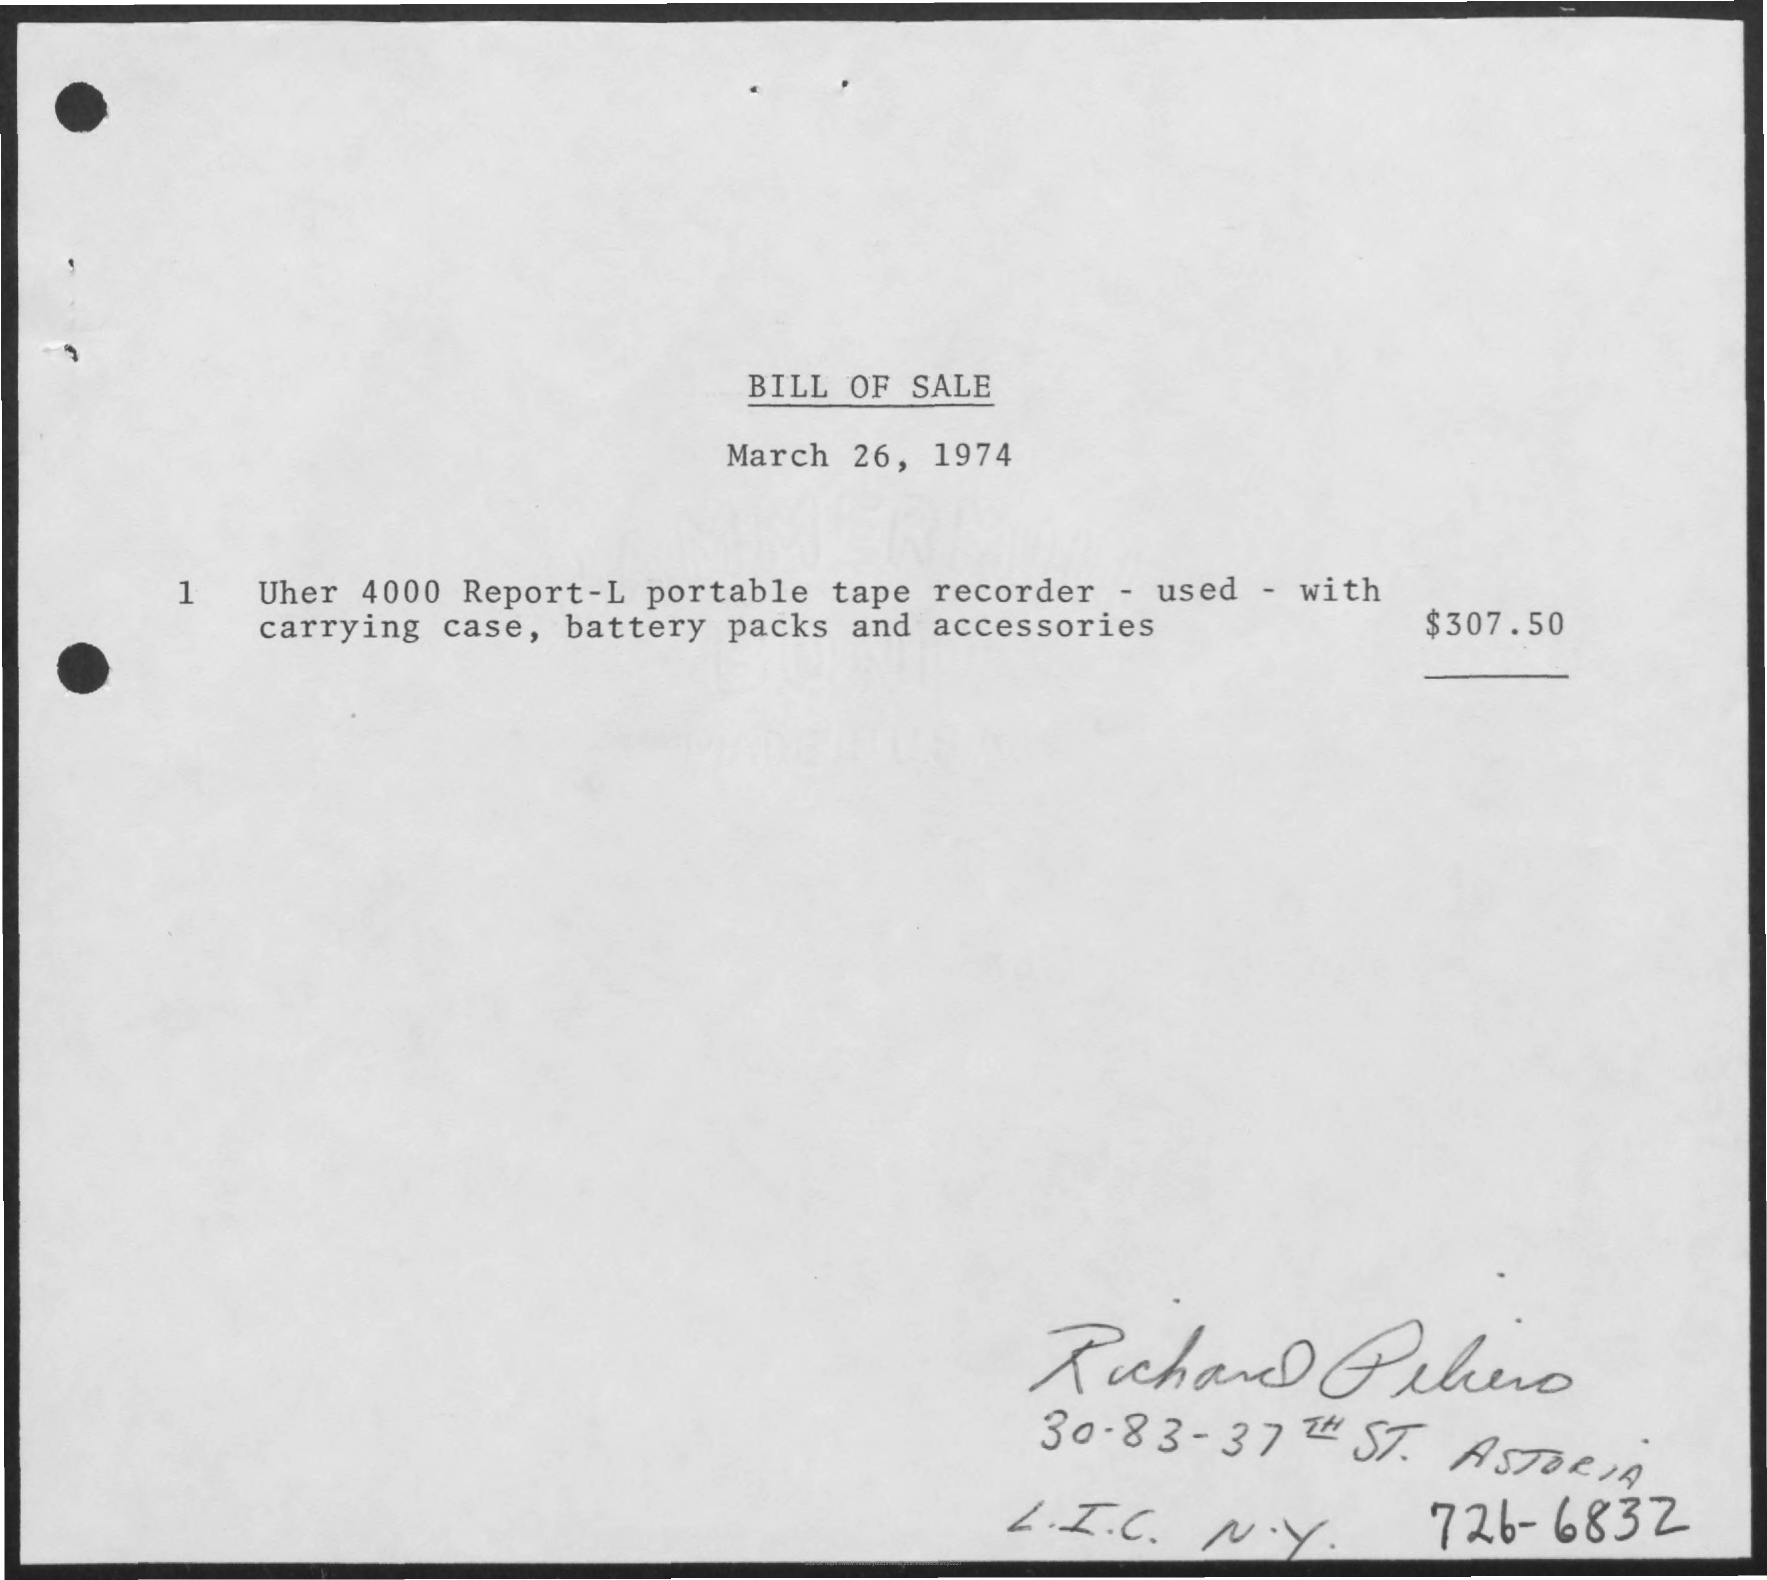Indicate a few pertinent items in this graphic. The date on the document is March 26, 1974. The document is titled "Bill of Sale. 